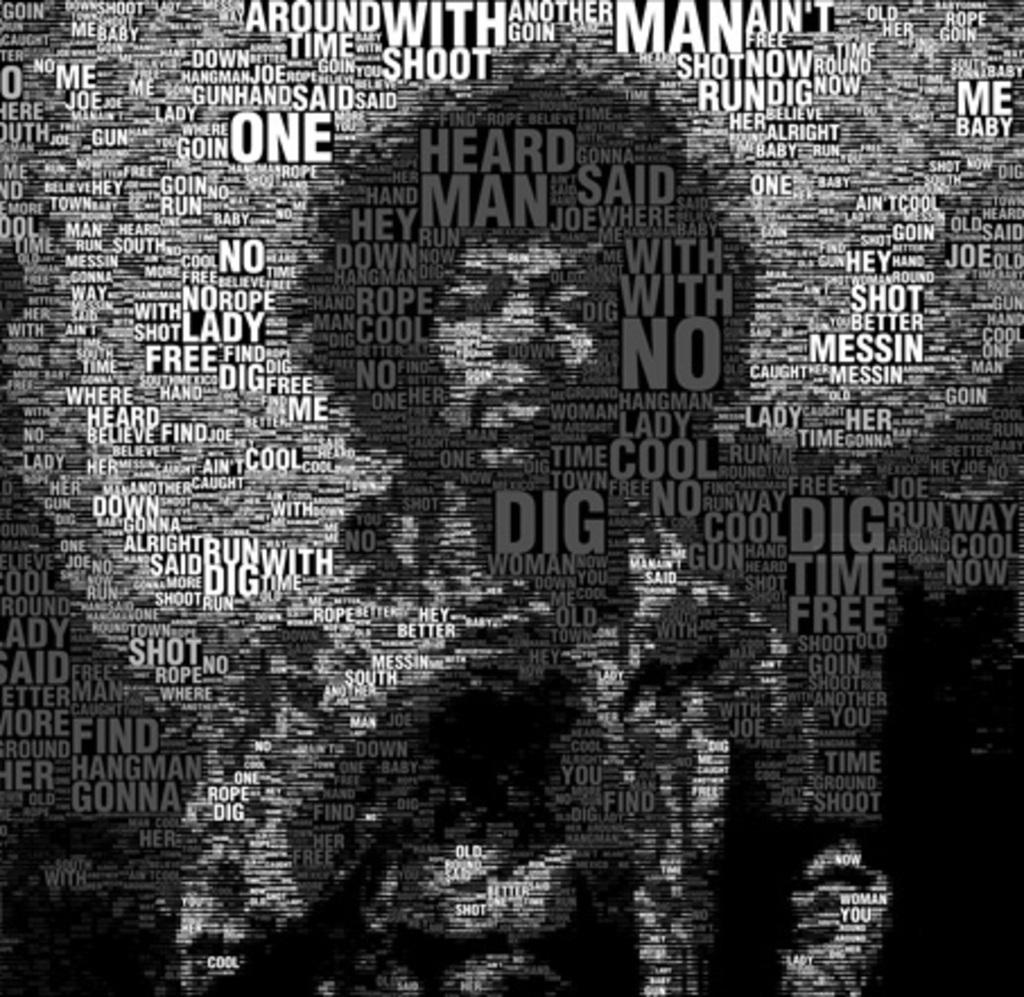<image>
Describe the image concisely. A word cloud type of graphic contains the word "dig" multiple times. 